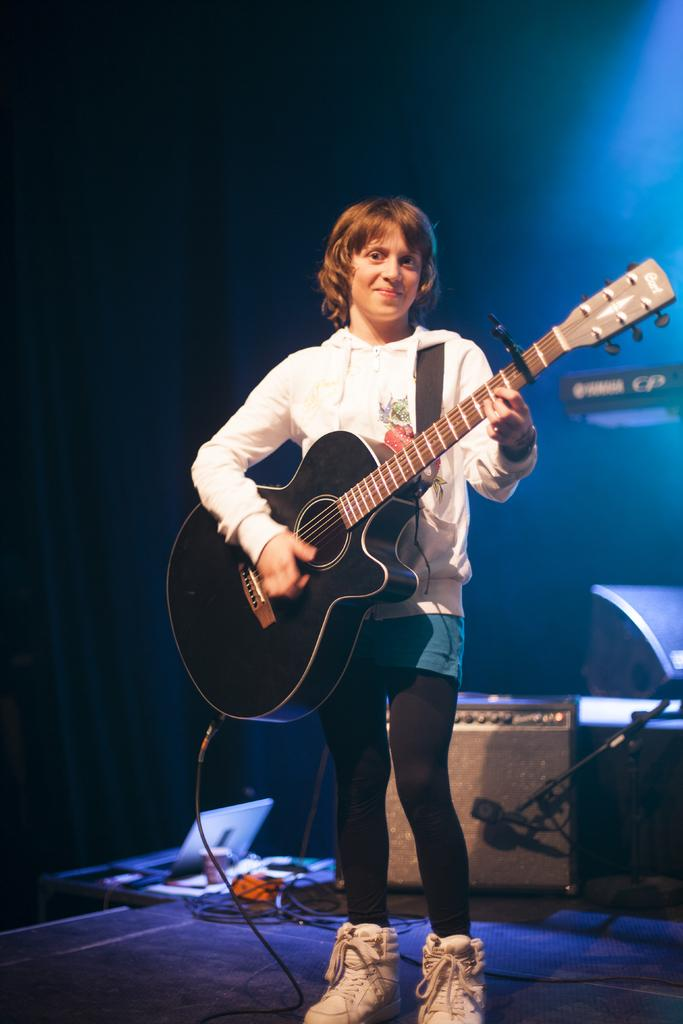What object can be seen in the image? A: There is a box in the image. Who is present in the image? There is a woman in the image. What is the woman holding in the image? The woman is holding a guitar. What magical detail can be seen on the guitar in the image? There is no magical detail present on the guitar in the image; it appears to be a regular guitar. What discovery was made by the woman in the image? There is no indication of a discovery being made by the woman in the image. 